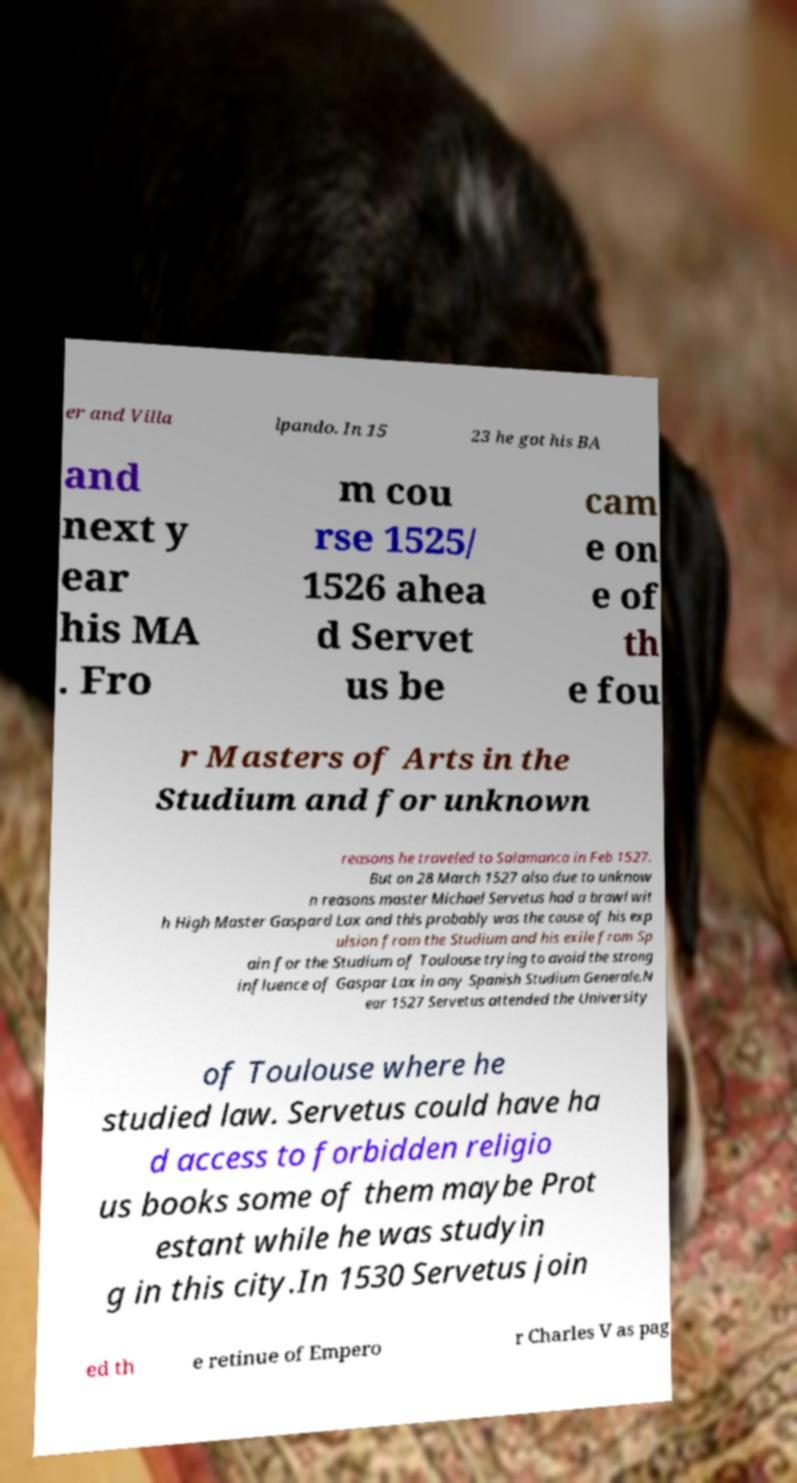I need the written content from this picture converted into text. Can you do that? er and Villa lpando. In 15 23 he got his BA and next y ear his MA . Fro m cou rse 1525/ 1526 ahea d Servet us be cam e on e of th e fou r Masters of Arts in the Studium and for unknown reasons he traveled to Salamanca in Feb 1527. But on 28 March 1527 also due to unknow n reasons master Michael Servetus had a brawl wit h High Master Gaspard Lax and this probably was the cause of his exp ulsion from the Studium and his exile from Sp ain for the Studium of Toulouse trying to avoid the strong influence of Gaspar Lax in any Spanish Studium Generale.N ear 1527 Servetus attended the University of Toulouse where he studied law. Servetus could have ha d access to forbidden religio us books some of them maybe Prot estant while he was studyin g in this city.In 1530 Servetus join ed th e retinue of Empero r Charles V as pag 